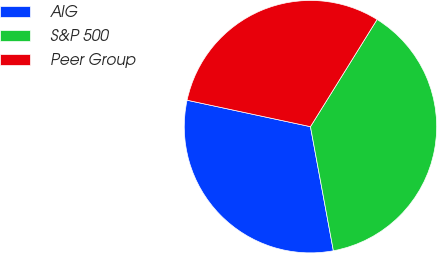Convert chart. <chart><loc_0><loc_0><loc_500><loc_500><pie_chart><fcel>AIG<fcel>S&P 500<fcel>Peer Group<nl><fcel>31.27%<fcel>38.24%<fcel>30.49%<nl></chart> 